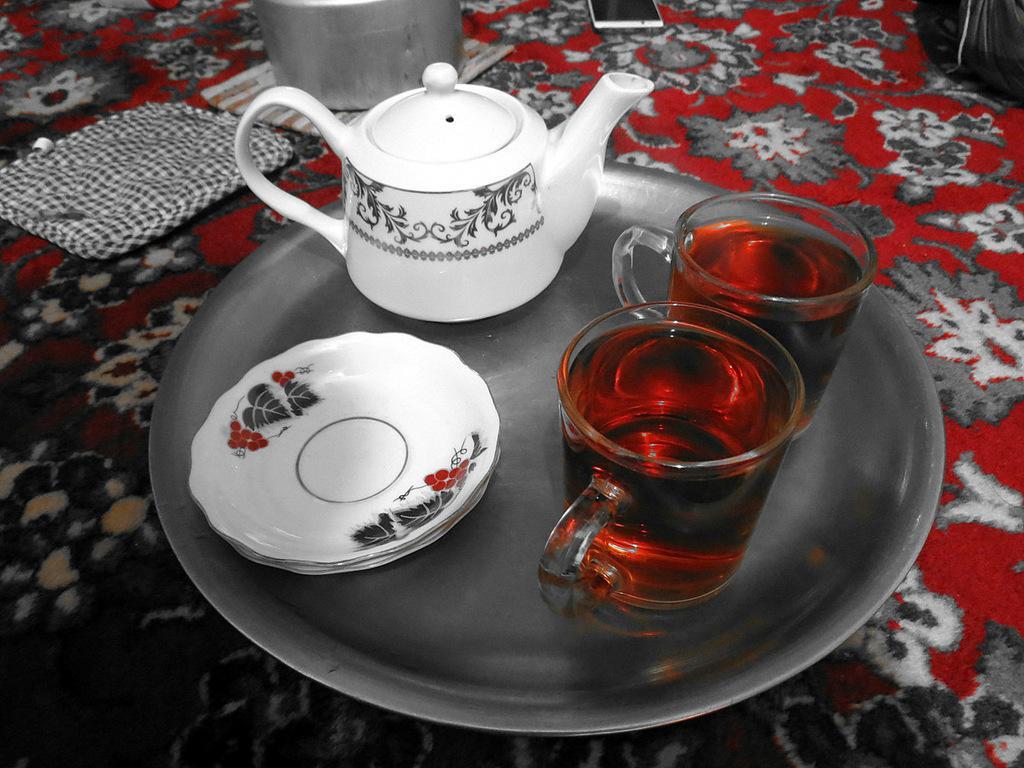Please provide a concise description of this image. This image consists of a plate in which kettle, saucer, tea cups are kept and a table cloth, vessel, mobile and a bag is visible which is kept on the table. This image is taken inside a room. 